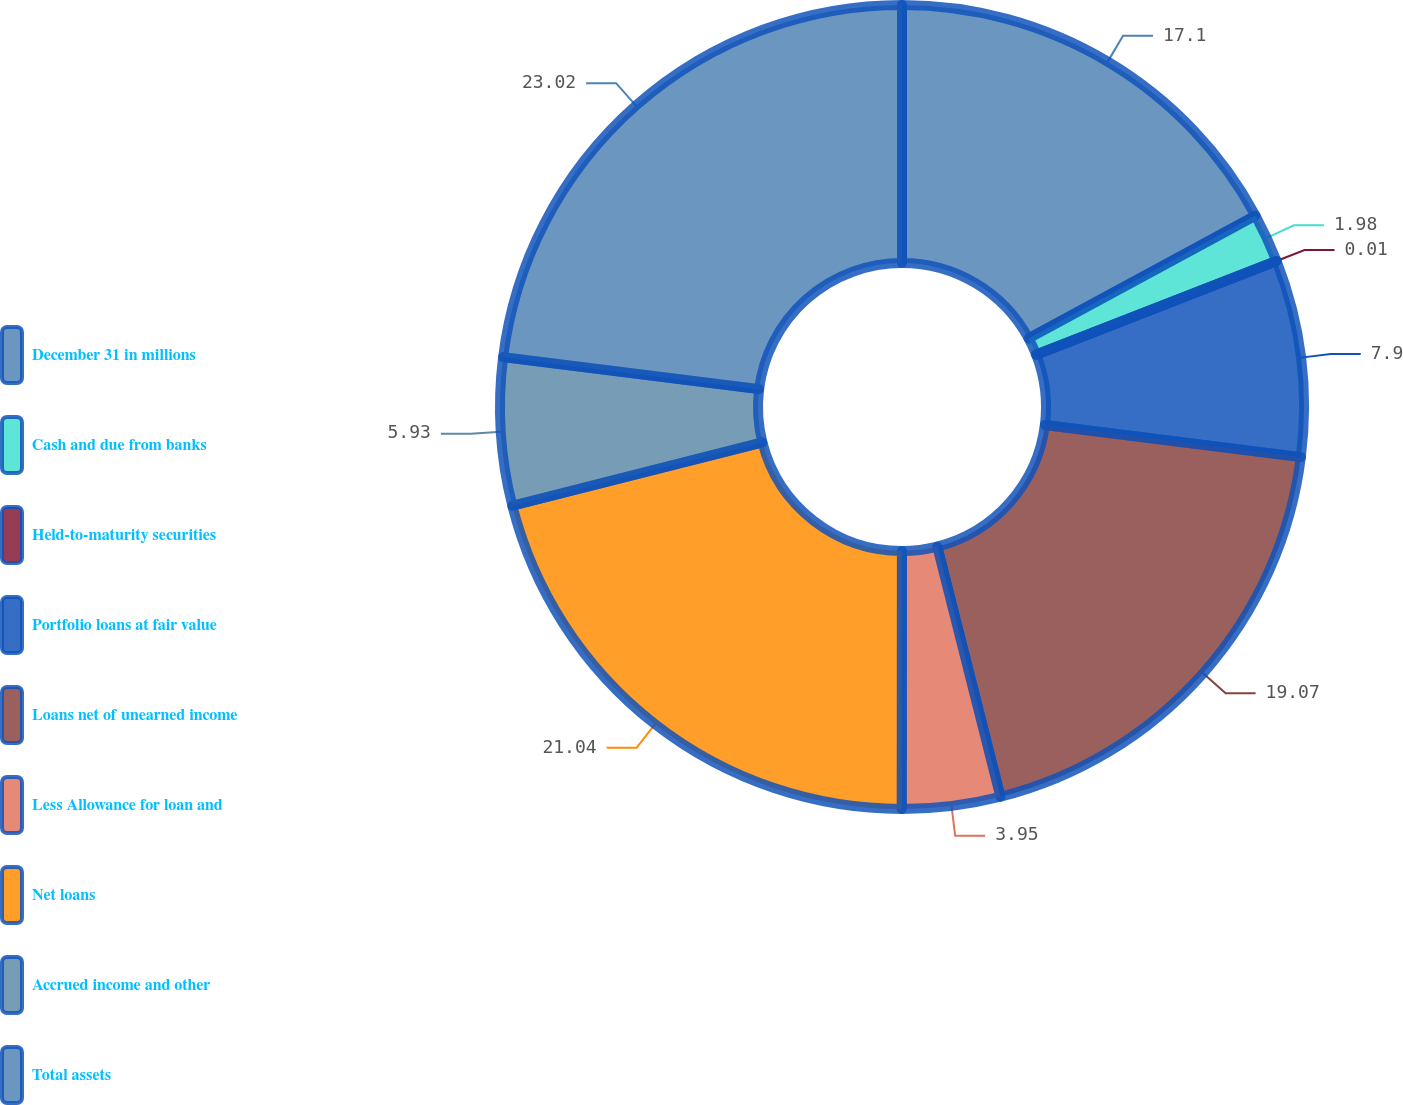Convert chart to OTSL. <chart><loc_0><loc_0><loc_500><loc_500><pie_chart><fcel>December 31 in millions<fcel>Cash and due from banks<fcel>Held-to-maturity securities<fcel>Portfolio loans at fair value<fcel>Loans net of unearned income<fcel>Less Allowance for loan and<fcel>Net loans<fcel>Accrued income and other<fcel>Total assets<nl><fcel>17.1%<fcel>1.98%<fcel>0.01%<fcel>7.9%<fcel>19.07%<fcel>3.95%<fcel>21.04%<fcel>5.93%<fcel>23.02%<nl></chart> 